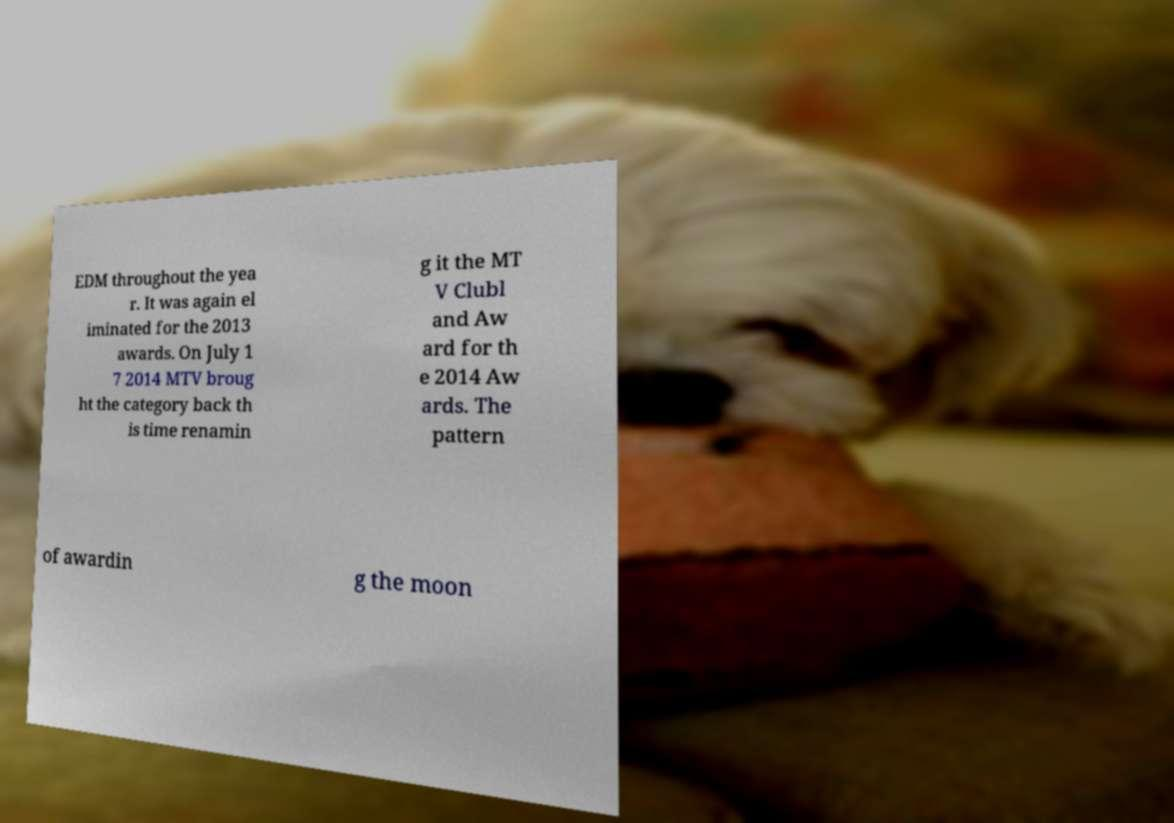I need the written content from this picture converted into text. Can you do that? EDM throughout the yea r. It was again el iminated for the 2013 awards. On July 1 7 2014 MTV broug ht the category back th is time renamin g it the MT V Clubl and Aw ard for th e 2014 Aw ards. The pattern of awardin g the moon 